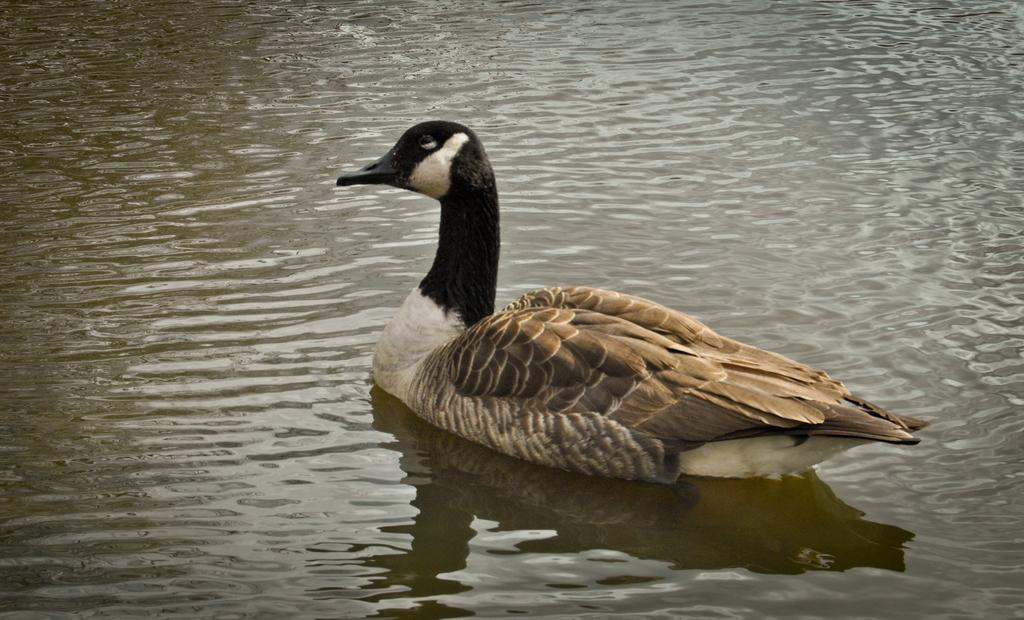What animal is present in the image? There is a duck in the image. Where is the duck located? The duck is on the water. What can be observed about the duck's reflection in the water? The image shows the reflection of the duck in the water. What type of juice is being served at the religious ceremony in the image? There is no religious ceremony or juice present in the image; it features a duck on the water with its reflection. 